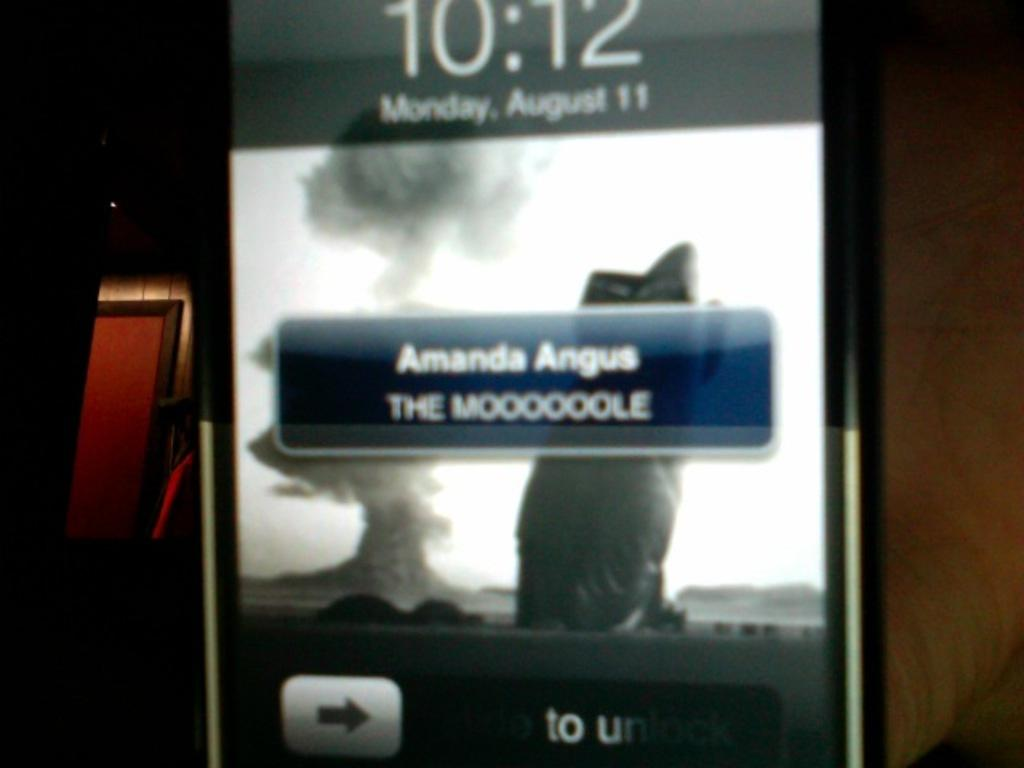<image>
Relay a brief, clear account of the picture shown. A phone shows a message from Amanda Angus on its lock screen. 